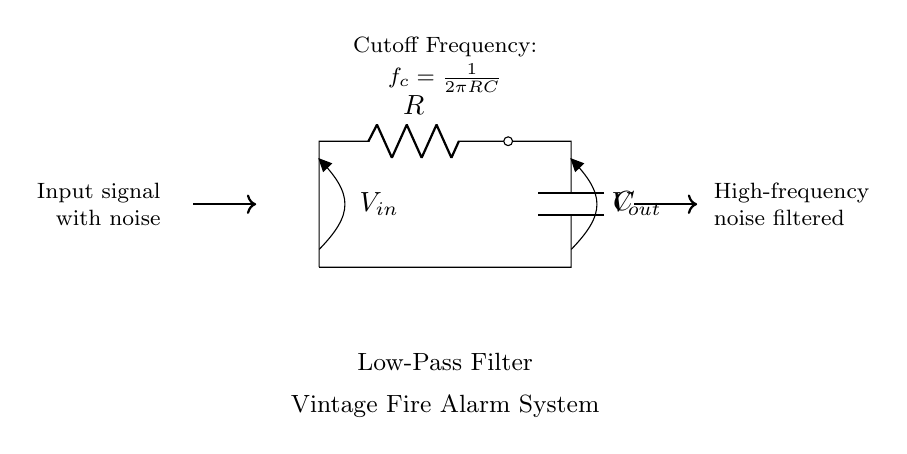What type of filter is shown in the circuit? The circuit is a low-pass filter, which allows low-frequency signals to pass while attenuating high-frequency signals. This is indicated by the label in the diagram.
Answer: Low-pass filter What components are used in this circuit? The circuit includes a resistor and a capacitor, as labeled R and C, respectively. These components are key in forming the filter.
Answer: Resistor and capacitor What is the output voltage referred to in the circuit? The output voltage, labeled as Vout, is the voltage across the capacitor, which is affected by the filtered input signal.
Answer: Vout What is the purpose of this low-pass filter in vintage fire alarm systems? The filter reduces high-frequency noise that could cause false alarms, thereby improving the reliability of the fire alarm system by allowing only valid signals to trigger alarms.
Answer: To reduce false alarms What is the cutoff frequency formula in this low-pass filter? The formula shown is fc = 1/(2πRC), which calculates the frequency at which the output voltage is reduced to a certain level (typically 70.7% of Vmax), marking the transition from passband to stopband.
Answer: fc = 1/(2πRC) How does increasing the resistance (R) affect the cutoff frequency? Increasing R will lower the cutoff frequency, as they are inversely proportional in the cutoff frequency formula. This means that the filter will let through lower frequencies while blocking higher ones.
Answer: Lowers cutoff frequency What effect does the capacitor (C) have on this filter? The capacitor stores energy and its charge/discharge behavior together with the resistor determines the filter's response to varying frequencies, allowing lower frequencies to pass and filtering out high frequencies.
Answer: Filters high frequencies 